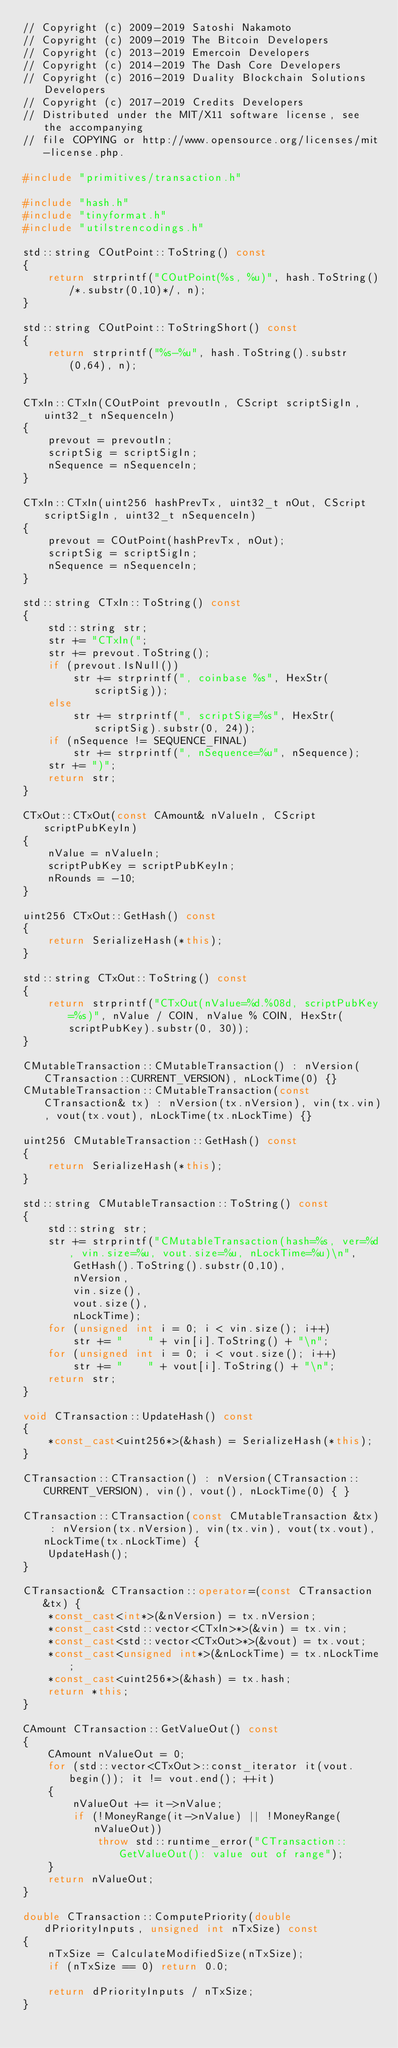<code> <loc_0><loc_0><loc_500><loc_500><_C++_>// Copyright (c) 2009-2019 Satoshi Nakamoto
// Copyright (c) 2009-2019 The Bitcoin Developers
// Copyright (c) 2013-2019 Emercoin Developers
// Copyright (c) 2014-2019 The Dash Core Developers
// Copyright (c) 2016-2019 Duality Blockchain Solutions Developers
// Copyright (c) 2017-2019 Credits Developers
// Distributed under the MIT/X11 software license, see the accompanying
// file COPYING or http://www.opensource.org/licenses/mit-license.php.

#include "primitives/transaction.h"

#include "hash.h"
#include "tinyformat.h"
#include "utilstrencodings.h"

std::string COutPoint::ToString() const
{
    return strprintf("COutPoint(%s, %u)", hash.ToString()/*.substr(0,10)*/, n);
}

std::string COutPoint::ToStringShort() const
{
    return strprintf("%s-%u", hash.ToString().substr(0,64), n);
}

CTxIn::CTxIn(COutPoint prevoutIn, CScript scriptSigIn, uint32_t nSequenceIn)
{
    prevout = prevoutIn;
    scriptSig = scriptSigIn;
    nSequence = nSequenceIn;
}

CTxIn::CTxIn(uint256 hashPrevTx, uint32_t nOut, CScript scriptSigIn, uint32_t nSequenceIn)
{
    prevout = COutPoint(hashPrevTx, nOut);
    scriptSig = scriptSigIn;
    nSequence = nSequenceIn;
}

std::string CTxIn::ToString() const
{
    std::string str;
    str += "CTxIn(";
    str += prevout.ToString();
    if (prevout.IsNull())
        str += strprintf(", coinbase %s", HexStr(scriptSig));
    else
        str += strprintf(", scriptSig=%s", HexStr(scriptSig).substr(0, 24));
    if (nSequence != SEQUENCE_FINAL)
        str += strprintf(", nSequence=%u", nSequence);
    str += ")";
    return str;
}

CTxOut::CTxOut(const CAmount& nValueIn, CScript scriptPubKeyIn)
{
    nValue = nValueIn;
    scriptPubKey = scriptPubKeyIn;
    nRounds = -10;
}

uint256 CTxOut::GetHash() const
{
    return SerializeHash(*this);
}

std::string CTxOut::ToString() const
{
    return strprintf("CTxOut(nValue=%d.%08d, scriptPubKey=%s)", nValue / COIN, nValue % COIN, HexStr(scriptPubKey).substr(0, 30));
}

CMutableTransaction::CMutableTransaction() : nVersion(CTransaction::CURRENT_VERSION), nLockTime(0) {}
CMutableTransaction::CMutableTransaction(const CTransaction& tx) : nVersion(tx.nVersion), vin(tx.vin), vout(tx.vout), nLockTime(tx.nLockTime) {}

uint256 CMutableTransaction::GetHash() const
{
    return SerializeHash(*this);
}

std::string CMutableTransaction::ToString() const
{
    std::string str;
    str += strprintf("CMutableTransaction(hash=%s, ver=%d, vin.size=%u, vout.size=%u, nLockTime=%u)\n",
        GetHash().ToString().substr(0,10),
        nVersion,
        vin.size(),
        vout.size(),
        nLockTime);
    for (unsigned int i = 0; i < vin.size(); i++)
        str += "    " + vin[i].ToString() + "\n";
    for (unsigned int i = 0; i < vout.size(); i++)
        str += "    " + vout[i].ToString() + "\n";
    return str;
}

void CTransaction::UpdateHash() const
{
    *const_cast<uint256*>(&hash) = SerializeHash(*this);
}

CTransaction::CTransaction() : nVersion(CTransaction::CURRENT_VERSION), vin(), vout(), nLockTime(0) { }

CTransaction::CTransaction(const CMutableTransaction &tx) : nVersion(tx.nVersion), vin(tx.vin), vout(tx.vout), nLockTime(tx.nLockTime) {
    UpdateHash();
}

CTransaction& CTransaction::operator=(const CTransaction &tx) {
    *const_cast<int*>(&nVersion) = tx.nVersion;
    *const_cast<std::vector<CTxIn>*>(&vin) = tx.vin;
    *const_cast<std::vector<CTxOut>*>(&vout) = tx.vout;
    *const_cast<unsigned int*>(&nLockTime) = tx.nLockTime;
    *const_cast<uint256*>(&hash) = tx.hash;
    return *this;
}

CAmount CTransaction::GetValueOut() const
{
    CAmount nValueOut = 0;
    for (std::vector<CTxOut>::const_iterator it(vout.begin()); it != vout.end(); ++it)
    {
        nValueOut += it->nValue;
        if (!MoneyRange(it->nValue) || !MoneyRange(nValueOut))
            throw std::runtime_error("CTransaction::GetValueOut(): value out of range");
    }
    return nValueOut;
}

double CTransaction::ComputePriority(double dPriorityInputs, unsigned int nTxSize) const
{
    nTxSize = CalculateModifiedSize(nTxSize);
    if (nTxSize == 0) return 0.0;

    return dPriorityInputs / nTxSize;
}
</code> 